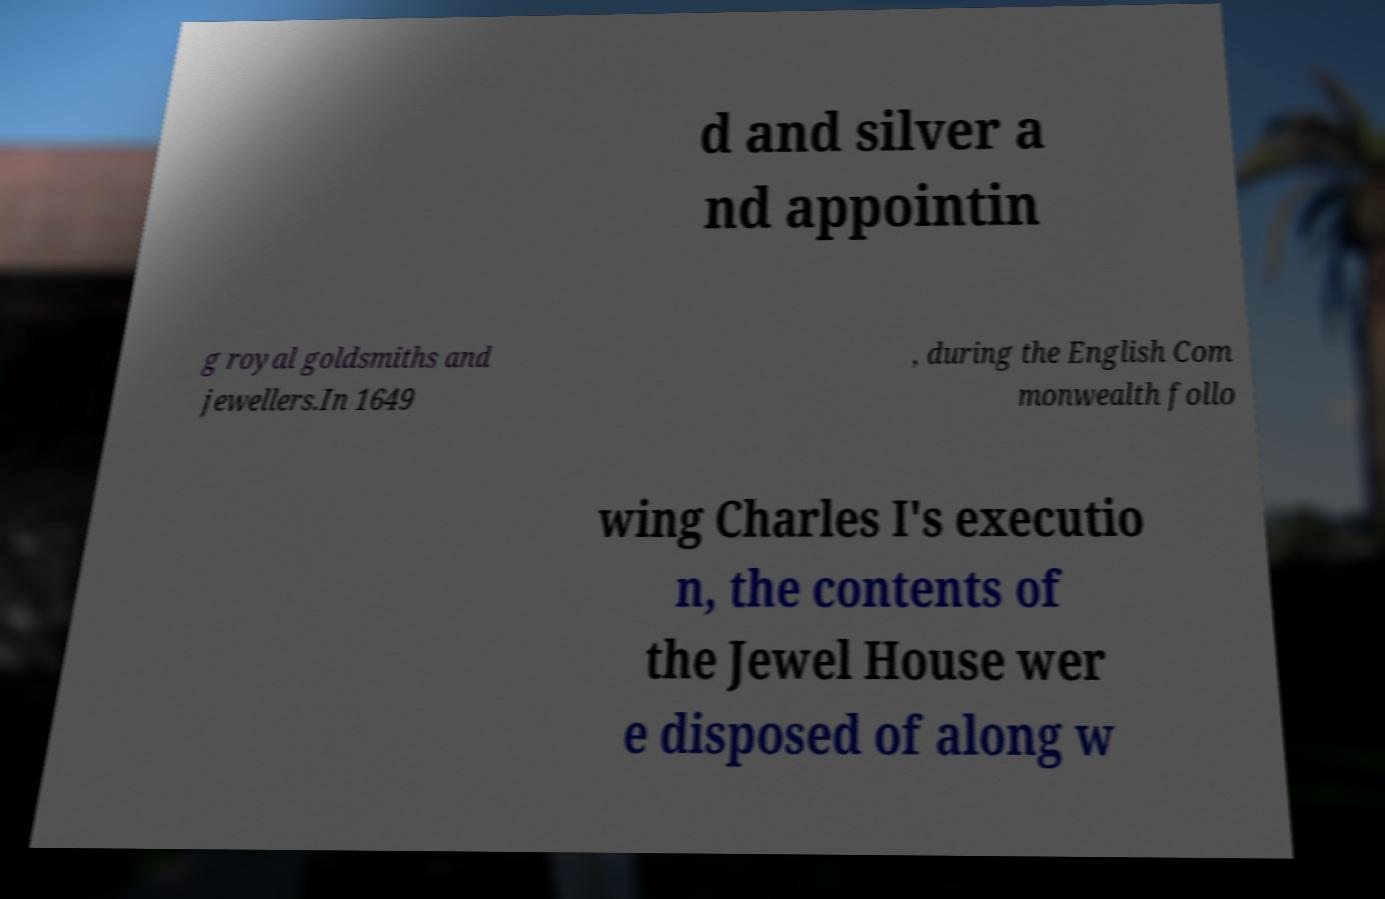What messages or text are displayed in this image? I need them in a readable, typed format. d and silver a nd appointin g royal goldsmiths and jewellers.In 1649 , during the English Com monwealth follo wing Charles I's executio n, the contents of the Jewel House wer e disposed of along w 